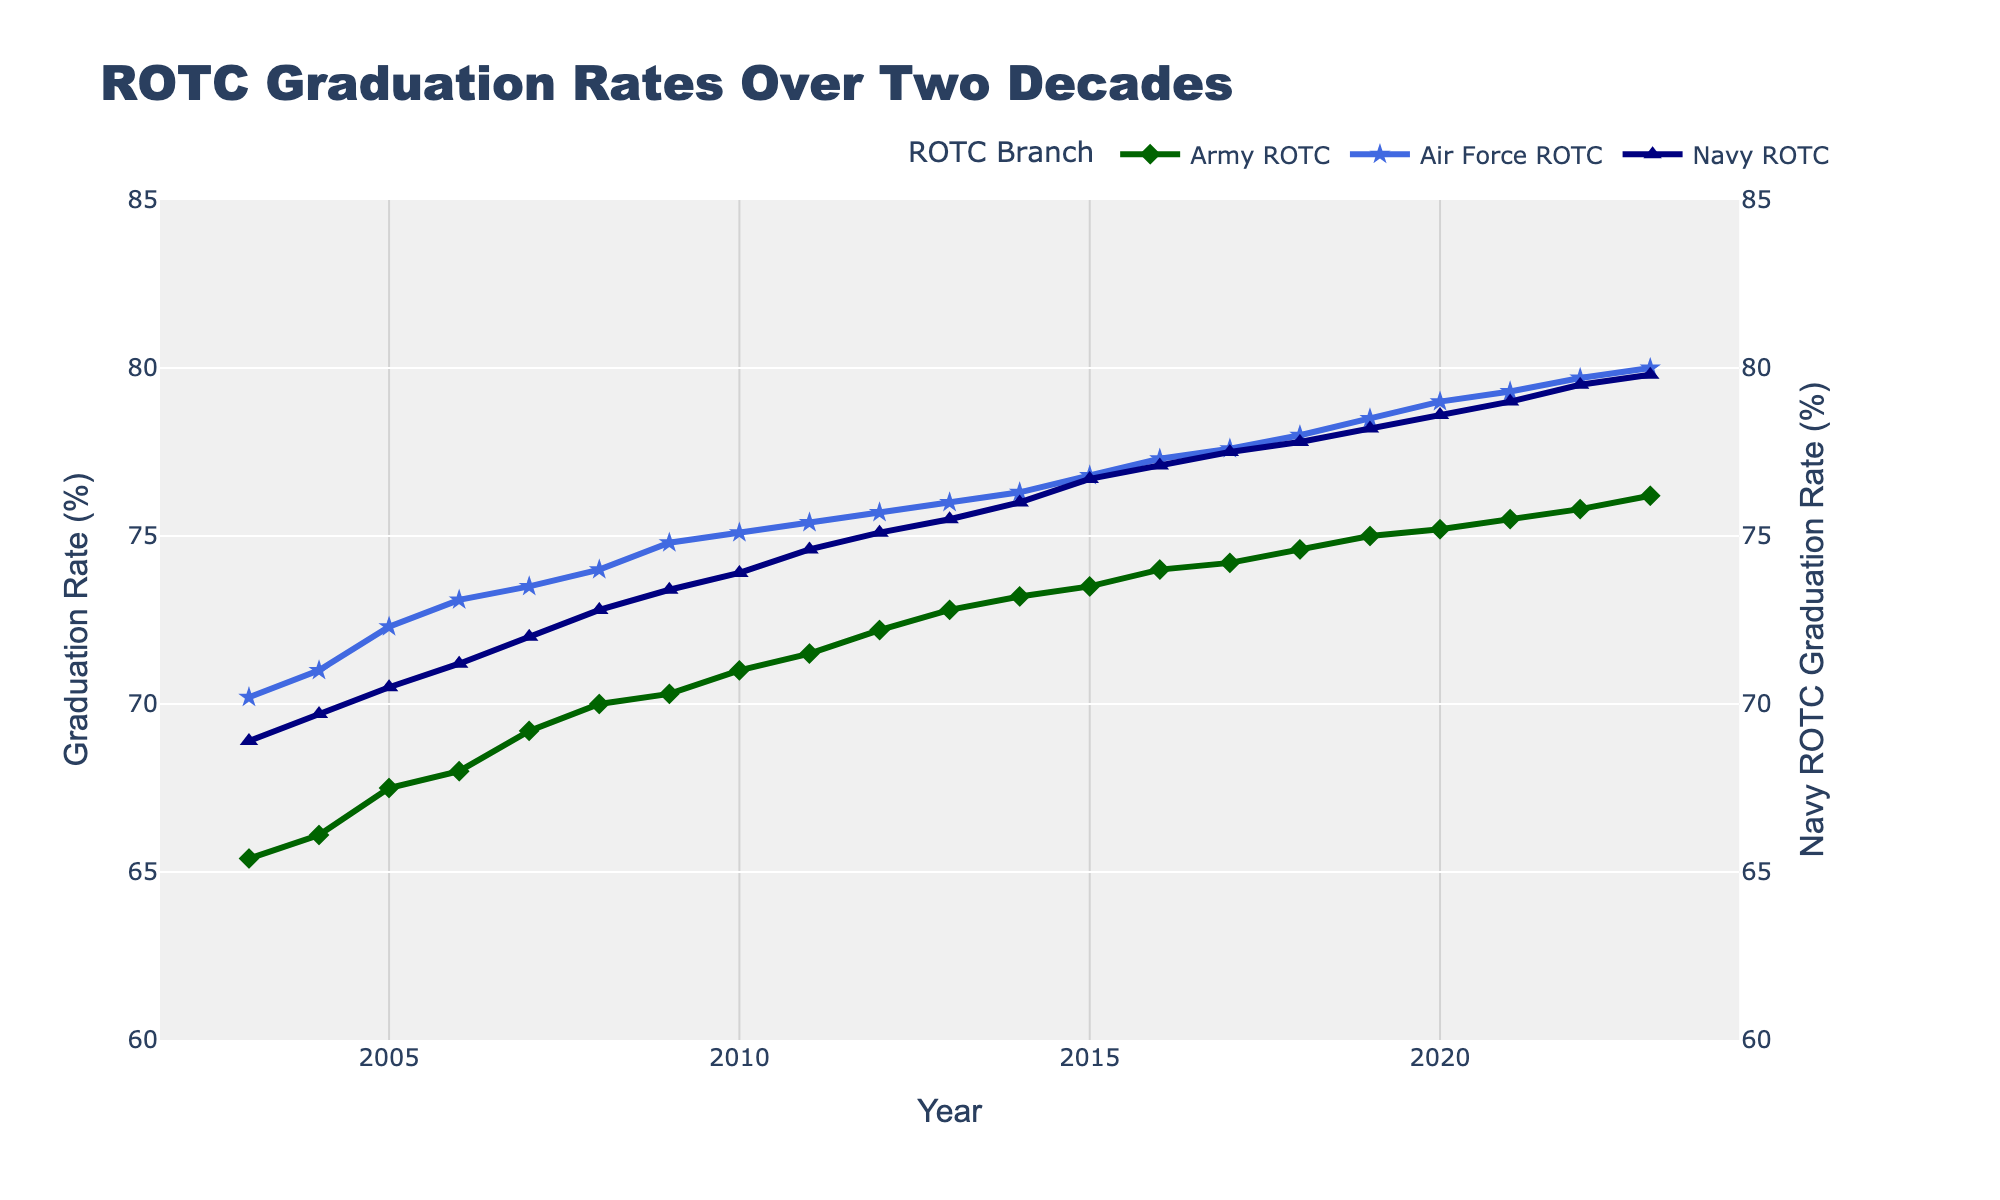What's the title of the figure? The title of the figure is displayed at the top and reads "ROTC Graduation Rates Over Two Decades."
Answer: ROTC Graduation Rates Over Two Decades How many ROTC branches are represented in the figure? The legend indicates three different branches are represented: Army ROTC, Air Force ROTC, and Navy ROTC.
Answer: Three Which ROTC branch had the highest graduation rate in 2023? By observing the data points for the year 2023, the Air Force ROTC had the highest graduation rate among the three branches.
Answer: Air Force ROTC Did the Army ROTC graduation rate increase or decrease from 2003 to 2023? By looking at the line plot for Army ROTC, it demonstrates a clear upward trend from 65.4 in 2003 to 76.2 in 2023.
Answer: Increase What was the graduation rate for the Navy ROTC in 2015? The line plot for Navy ROTC shows a point at the year 2015 which corresponds to a graduation rate of 76.7%.
Answer: 76.7% Which year had the smallest difference between Army ROTC and Navy ROTC graduation rates? To find this, we compare the differences for each year. The smallest difference is in 2009, where the difference is 70.3 - 73.4 = 3.1%.
Answer: 2009 How did the graduation rates for Air Force ROTC change between 2018 and 2023? From 2018 to 2023, Air Force ROTC graduation rates increased from 78.0% to 80.0%.
Answer: Increased by 2% What is the range of graduation rates for Army ROTC over these two decades? The lowest rate for Army ROTC is 65.4% in 2003 and the highest is 76.2% in 2023. The range is therefore 76.2 - 65.4 = 10.8%.
Answer: 10.8% Which branch has the most consistent graduation rate over the years? By observing the stability of the lines, the Army ROTC line shows the least variation and a steady upward trend, indicating consistency.
Answer: Army ROTC 